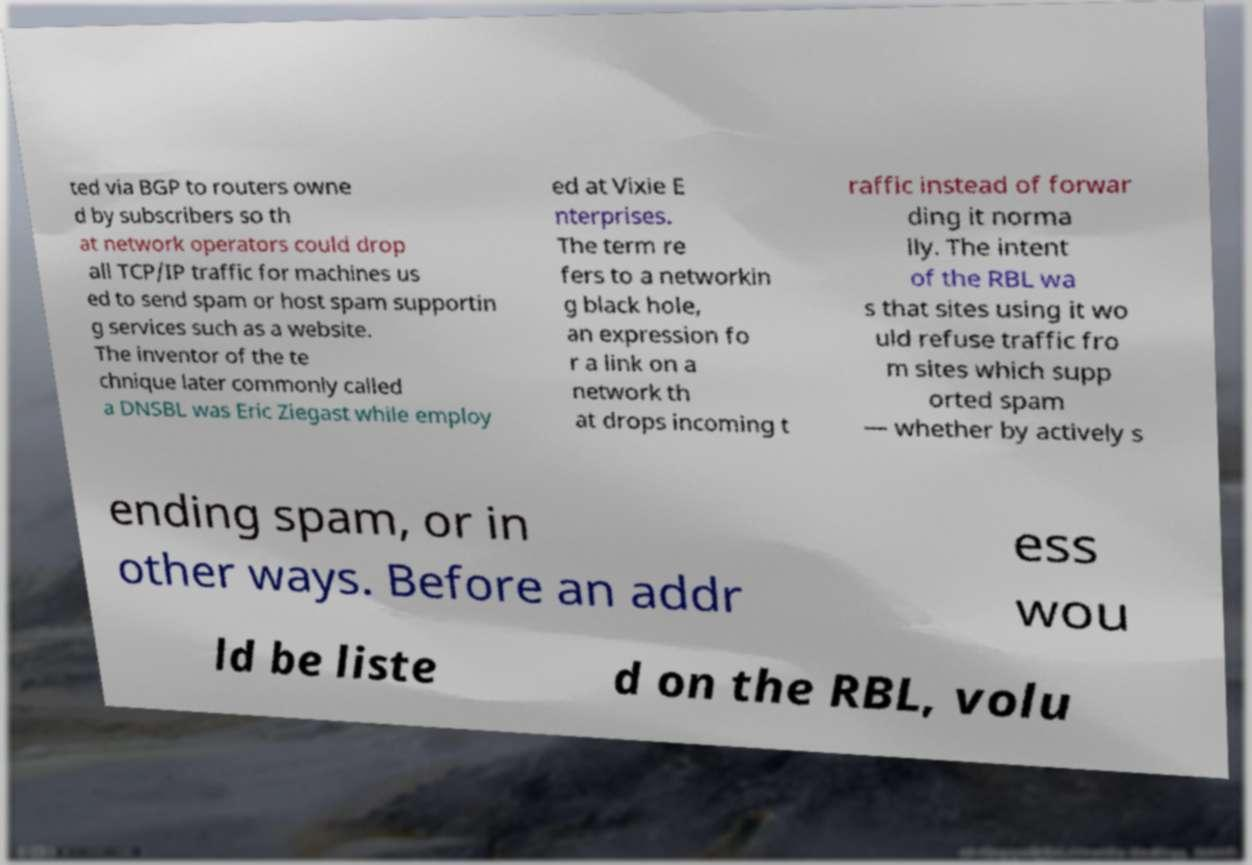There's text embedded in this image that I need extracted. Can you transcribe it verbatim? ted via BGP to routers owne d by subscribers so th at network operators could drop all TCP/IP traffic for machines us ed to send spam or host spam supportin g services such as a website. The inventor of the te chnique later commonly called a DNSBL was Eric Ziegast while employ ed at Vixie E nterprises. The term re fers to a networkin g black hole, an expression fo r a link on a network th at drops incoming t raffic instead of forwar ding it norma lly. The intent of the RBL wa s that sites using it wo uld refuse traffic fro m sites which supp orted spam — whether by actively s ending spam, or in other ways. Before an addr ess wou ld be liste d on the RBL, volu 